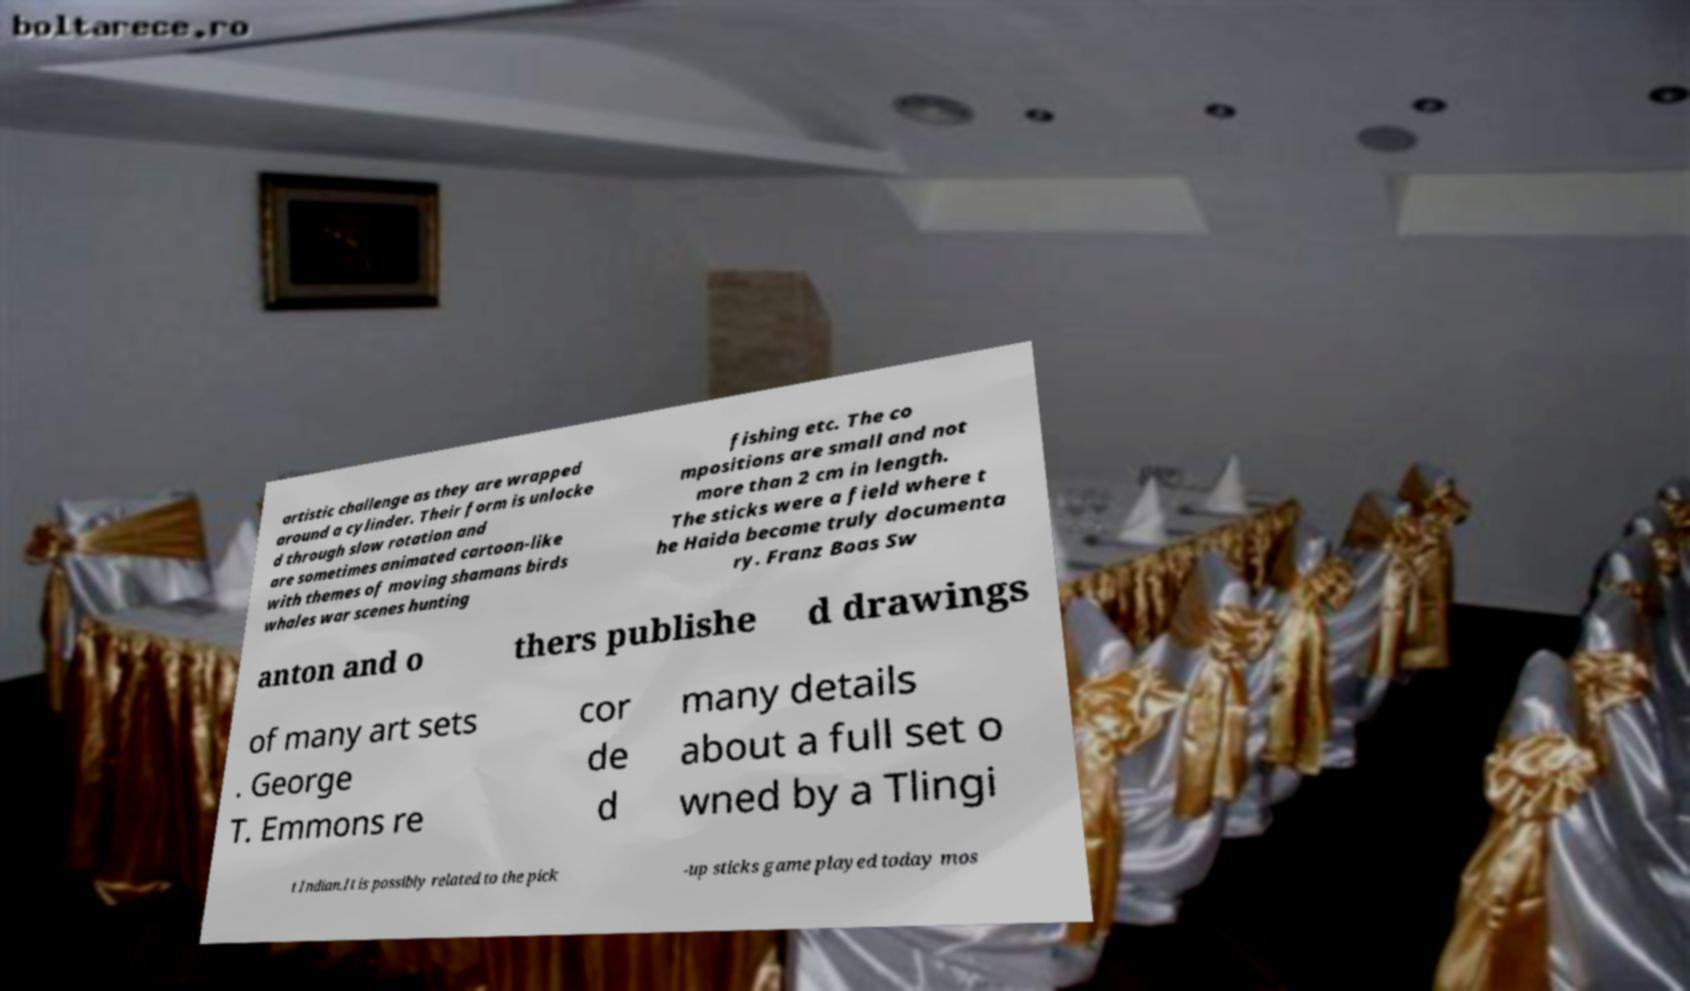Can you accurately transcribe the text from the provided image for me? artistic challenge as they are wrapped around a cylinder. Their form is unlocke d through slow rotation and are sometimes animated cartoon-like with themes of moving shamans birds whales war scenes hunting fishing etc. The co mpositions are small and not more than 2 cm in length. The sticks were a field where t he Haida became truly documenta ry. Franz Boas Sw anton and o thers publishe d drawings of many art sets . George T. Emmons re cor de d many details about a full set o wned by a Tlingi t Indian.It is possibly related to the pick -up sticks game played today mos 